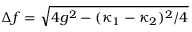<formula> <loc_0><loc_0><loc_500><loc_500>\Delta f = \sqrt { 4 g ^ { 2 } - ( { \kappa _ { 1 } - \kappa _ { 2 } } ) ^ { 2 } / 4 }</formula> 